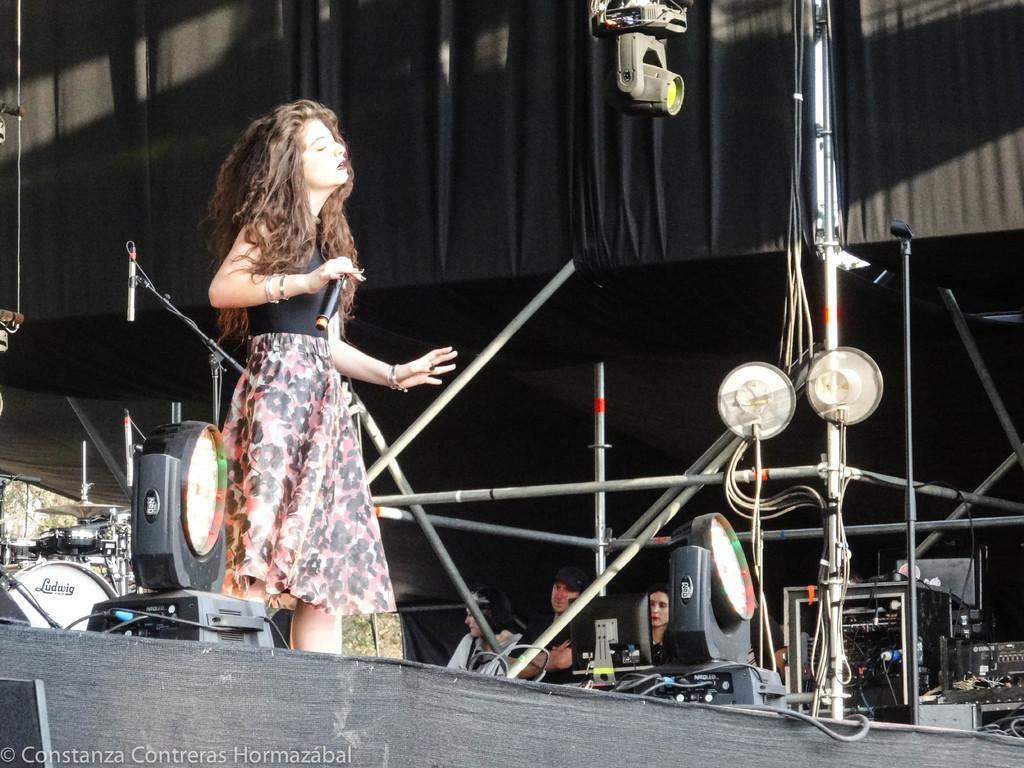Please provide a concise description of this image. This picture describes about group of people, on the left side of the image we can see a woman, she is holding a microphone, in front of her we can find few lights, metal rods and musical instruments, in the background we can see trees, at the left bottom of the image we can see some text. 